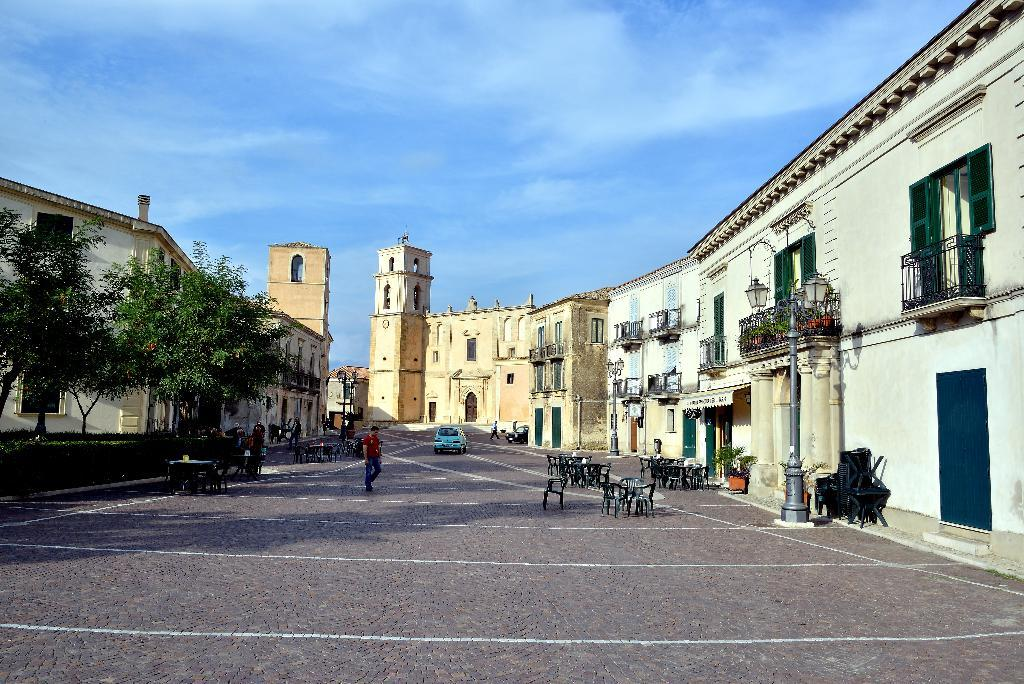What is the person in the image doing? There is a person walking on the road in the image. What type of furniture can be seen in the image? There are chairs in the image. What type of structures are visible in the image? There are buildings in the image. What type of vegetation is present in the image? There are trees in the image. What type of vehicle is in the image? There is a car in the image. What is visible in the sky in the image? Clouds are visible in the sky in the image. How do the lizards react to the person walking on the road in the image? There are no lizards present in the image, so their reaction cannot be determined. 